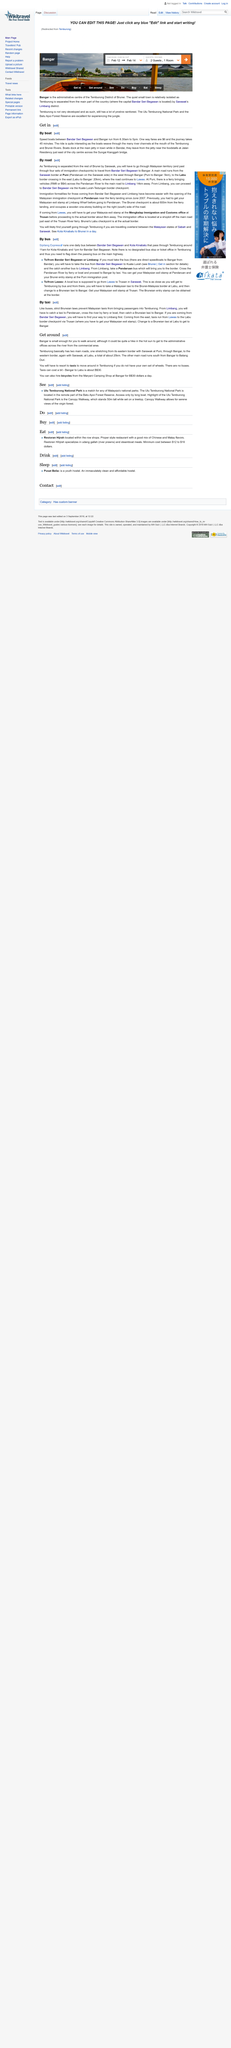Outline some significant characteristics in this image. A taxi, a four-wheeled vehicle, is available to transport you to Bangar. Yes, it is possible to reach Bangar by both boat and road. Temburong, which is separated from the rest of Brunei by Sarawak, is a district that is distinct from the rest of the country. The main jetty in town serves as a docking point for boats. Temburong has two main roads. 